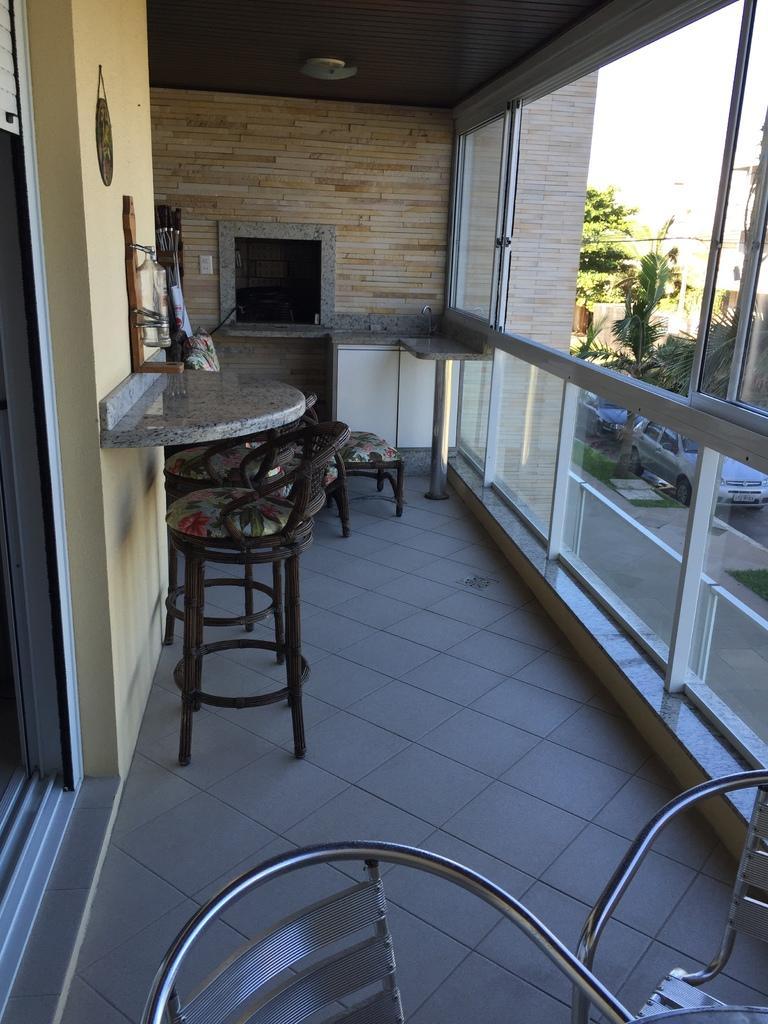How would you summarize this image in a sentence or two? In this image I can see few chairs. In background I can see a car and few trees. 